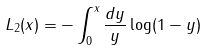<formula> <loc_0><loc_0><loc_500><loc_500>L _ { 2 } ( x ) = - \int _ { 0 } ^ { x } \frac { d y } { y } \log ( 1 - y )</formula> 